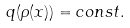Convert formula to latex. <formula><loc_0><loc_0><loc_500><loc_500>q ( \rho ( x ) ) = c o n s t .</formula> 